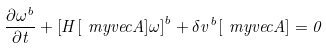<formula> <loc_0><loc_0><loc_500><loc_500>\frac { \partial \omega ^ { b } } { \partial t } + \left [ H [ \ m y v e c { A } ] \omega \right ] ^ { b } + \delta v ^ { b } [ \ m y v e c { A } ] = 0</formula> 